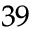<formula> <loc_0><loc_0><loc_500><loc_500>^ { 3 9 }</formula> 